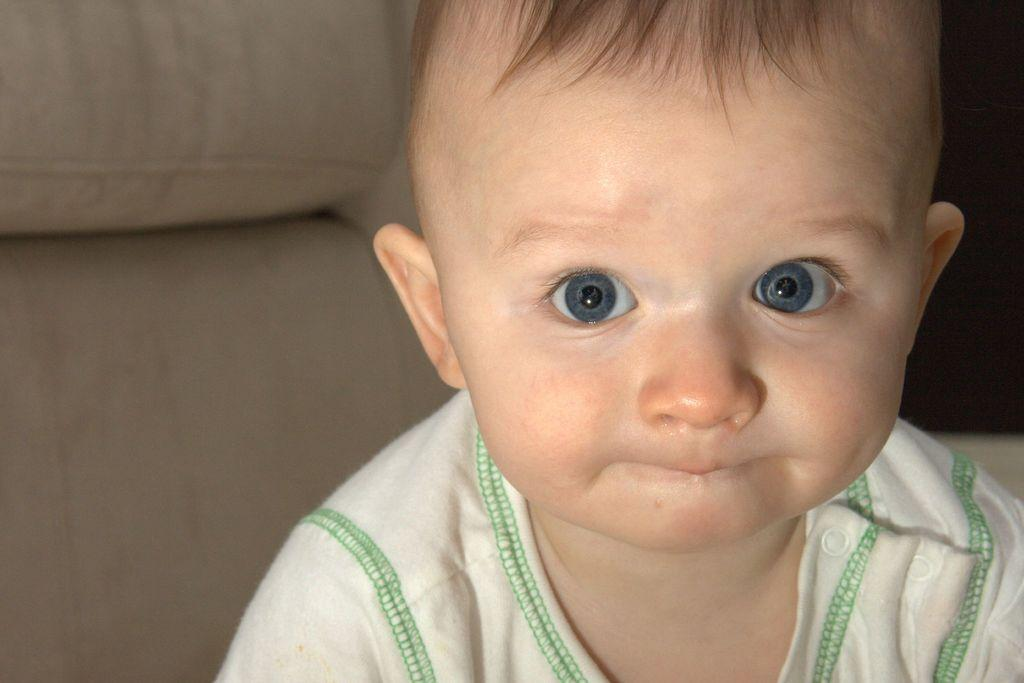What is the main subject of the image? There is a baby in the image. What is the baby wearing? The baby is wearing a white dress. What type of furniture is visible in the image? There is a sofa visible in the image. What color is the sofa? The sofa is in cream color. What type of work is the baby doing in the image? The baby is not working in the image, as they are a young child and not engaged in any work-related activities. 